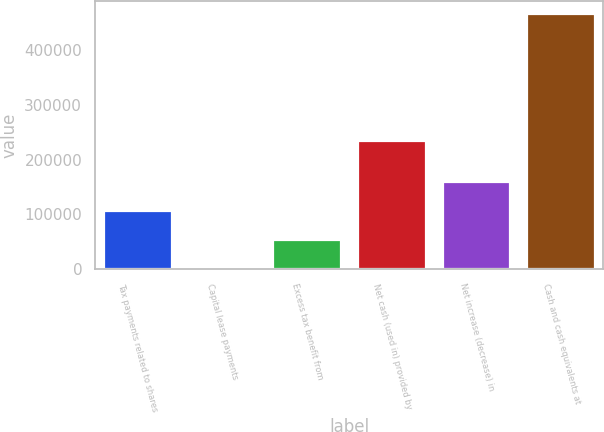<chart> <loc_0><loc_0><loc_500><loc_500><bar_chart><fcel>Tax payments related to shares<fcel>Capital lease payments<fcel>Excess tax benefit from<fcel>Net cash (used in) provided by<fcel>Net increase (decrease) in<fcel>Cash and cash equivalents at<nl><fcel>106030<fcel>454<fcel>53242<fcel>235016<fcel>158818<fcel>466603<nl></chart> 